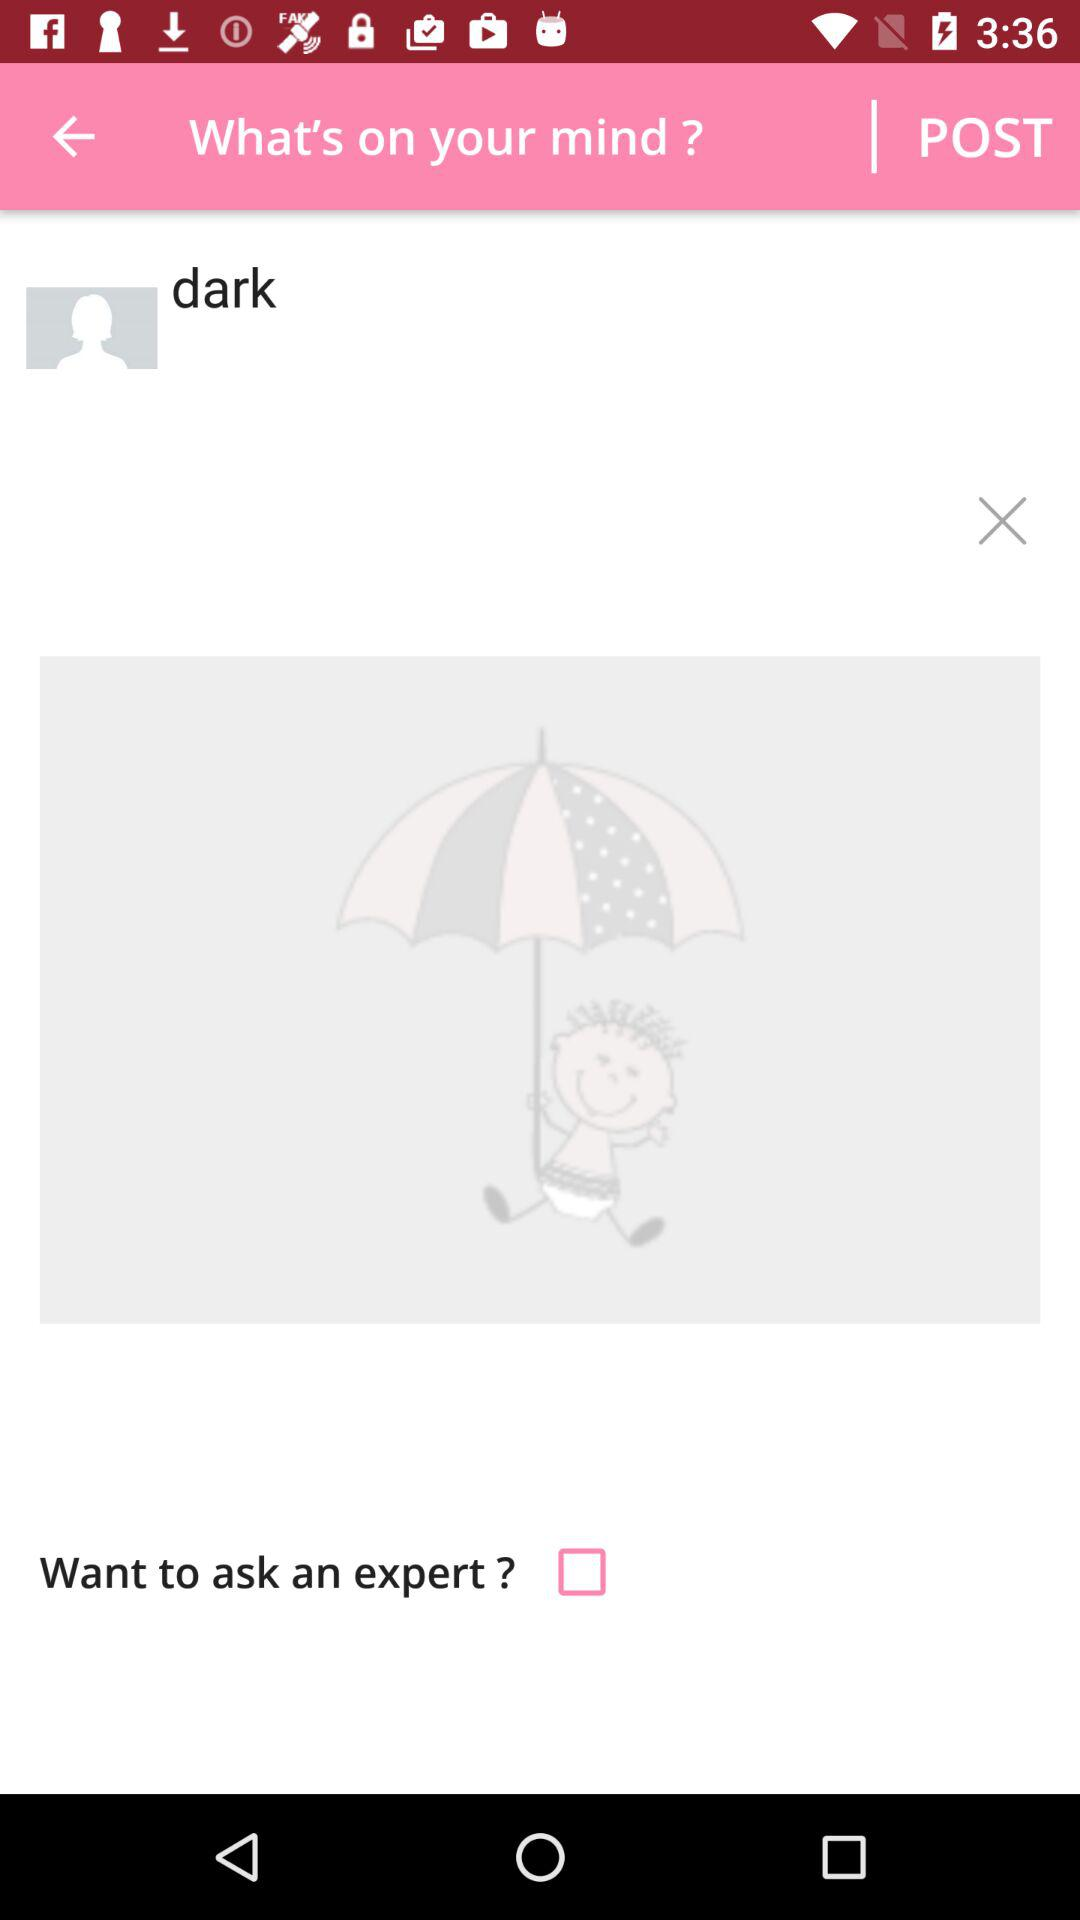What is the status of "Want to ask an expert?"? The status is "off". 